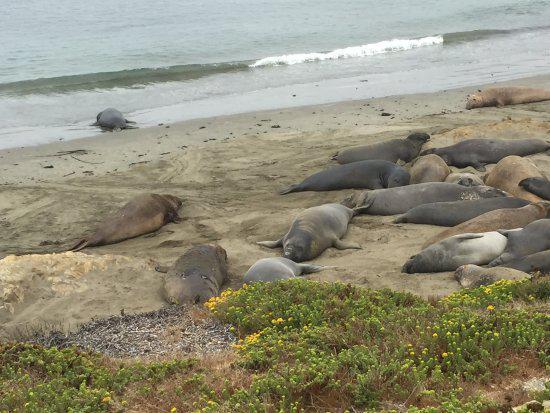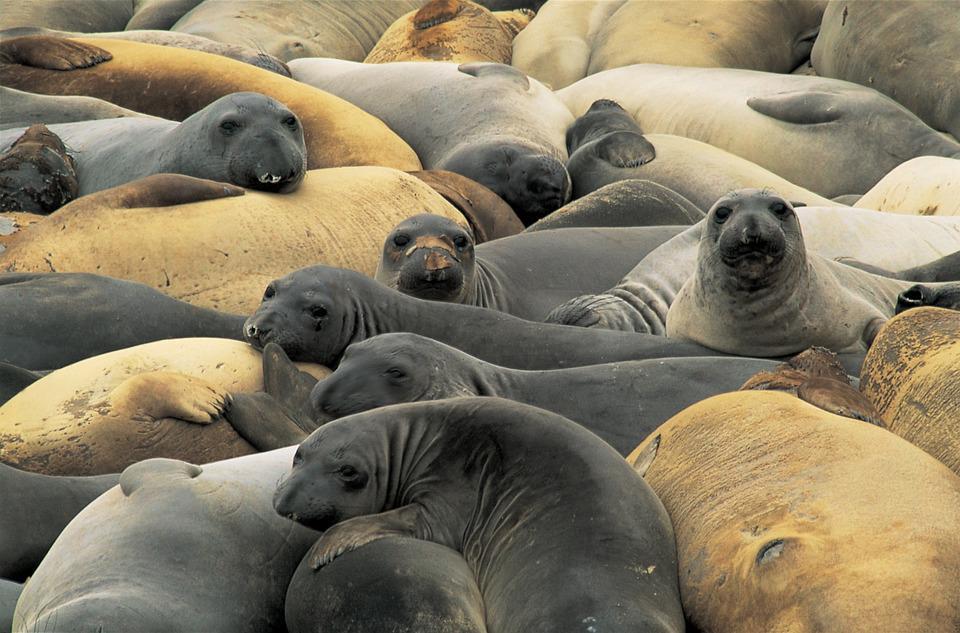The first image is the image on the left, the second image is the image on the right. For the images shown, is this caption "A juvenile sea lion can be seen near an adult sea lion." true? Answer yes or no. No. The first image is the image on the left, the second image is the image on the right. Considering the images on both sides, is "There are no more than four animals." valid? Answer yes or no. No. 